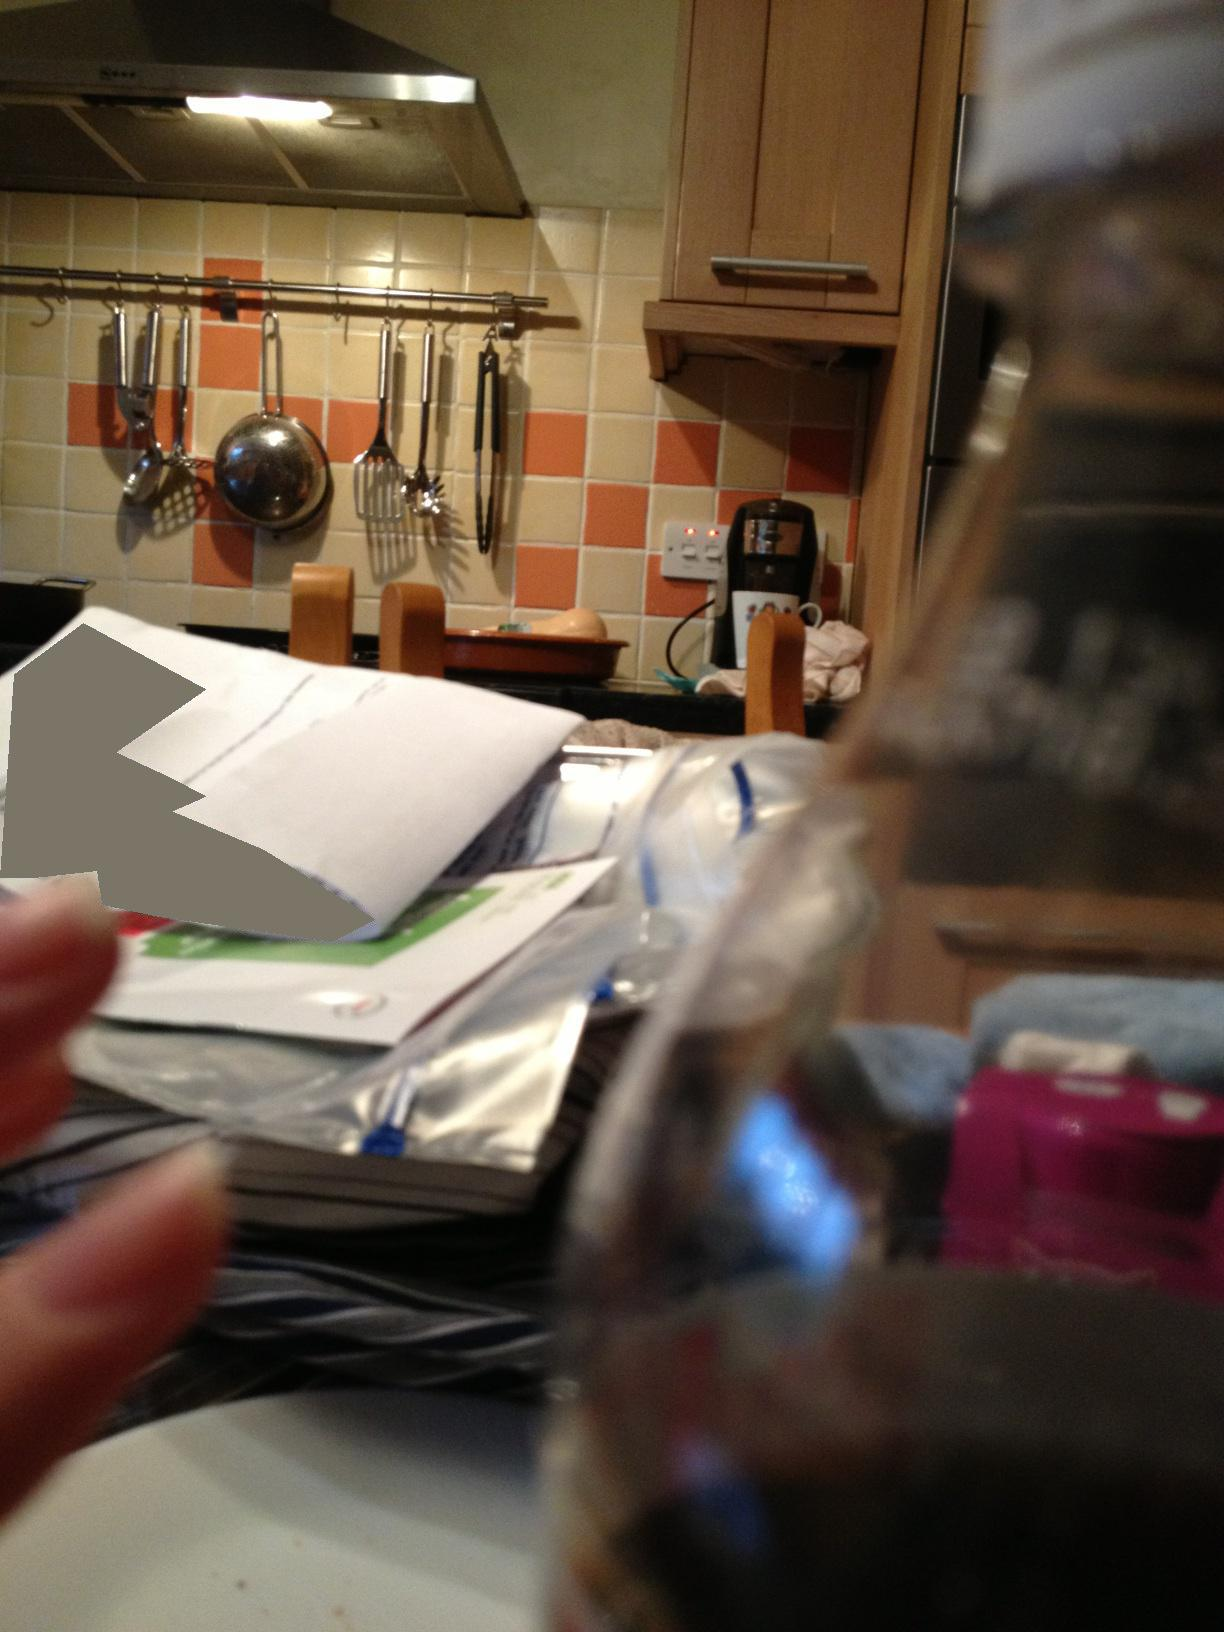What does the style of the kitchen tell us about the owner? The style of the kitchen, with its warm-colored tiles and wooden cabinets, suggests a homey, functional space. The use of hanging racks for utensils shows practicality and a preference for having tools within easy reach. The overall look gives off a lived-in vibe, indicating that the kitchen is well-used and central to the household's daily life. 